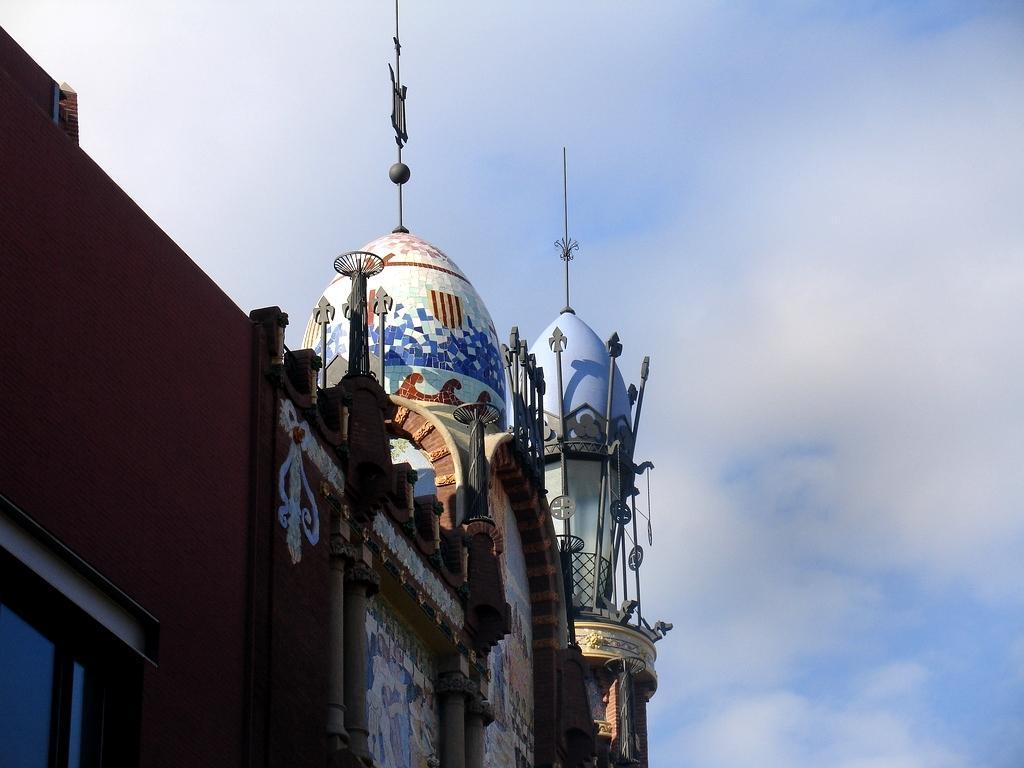In one or two sentences, can you explain what this image depicts? At the there is a sky. On the left side of the picture we can see a building. At the top of the building we can see a dome with multi colors. 